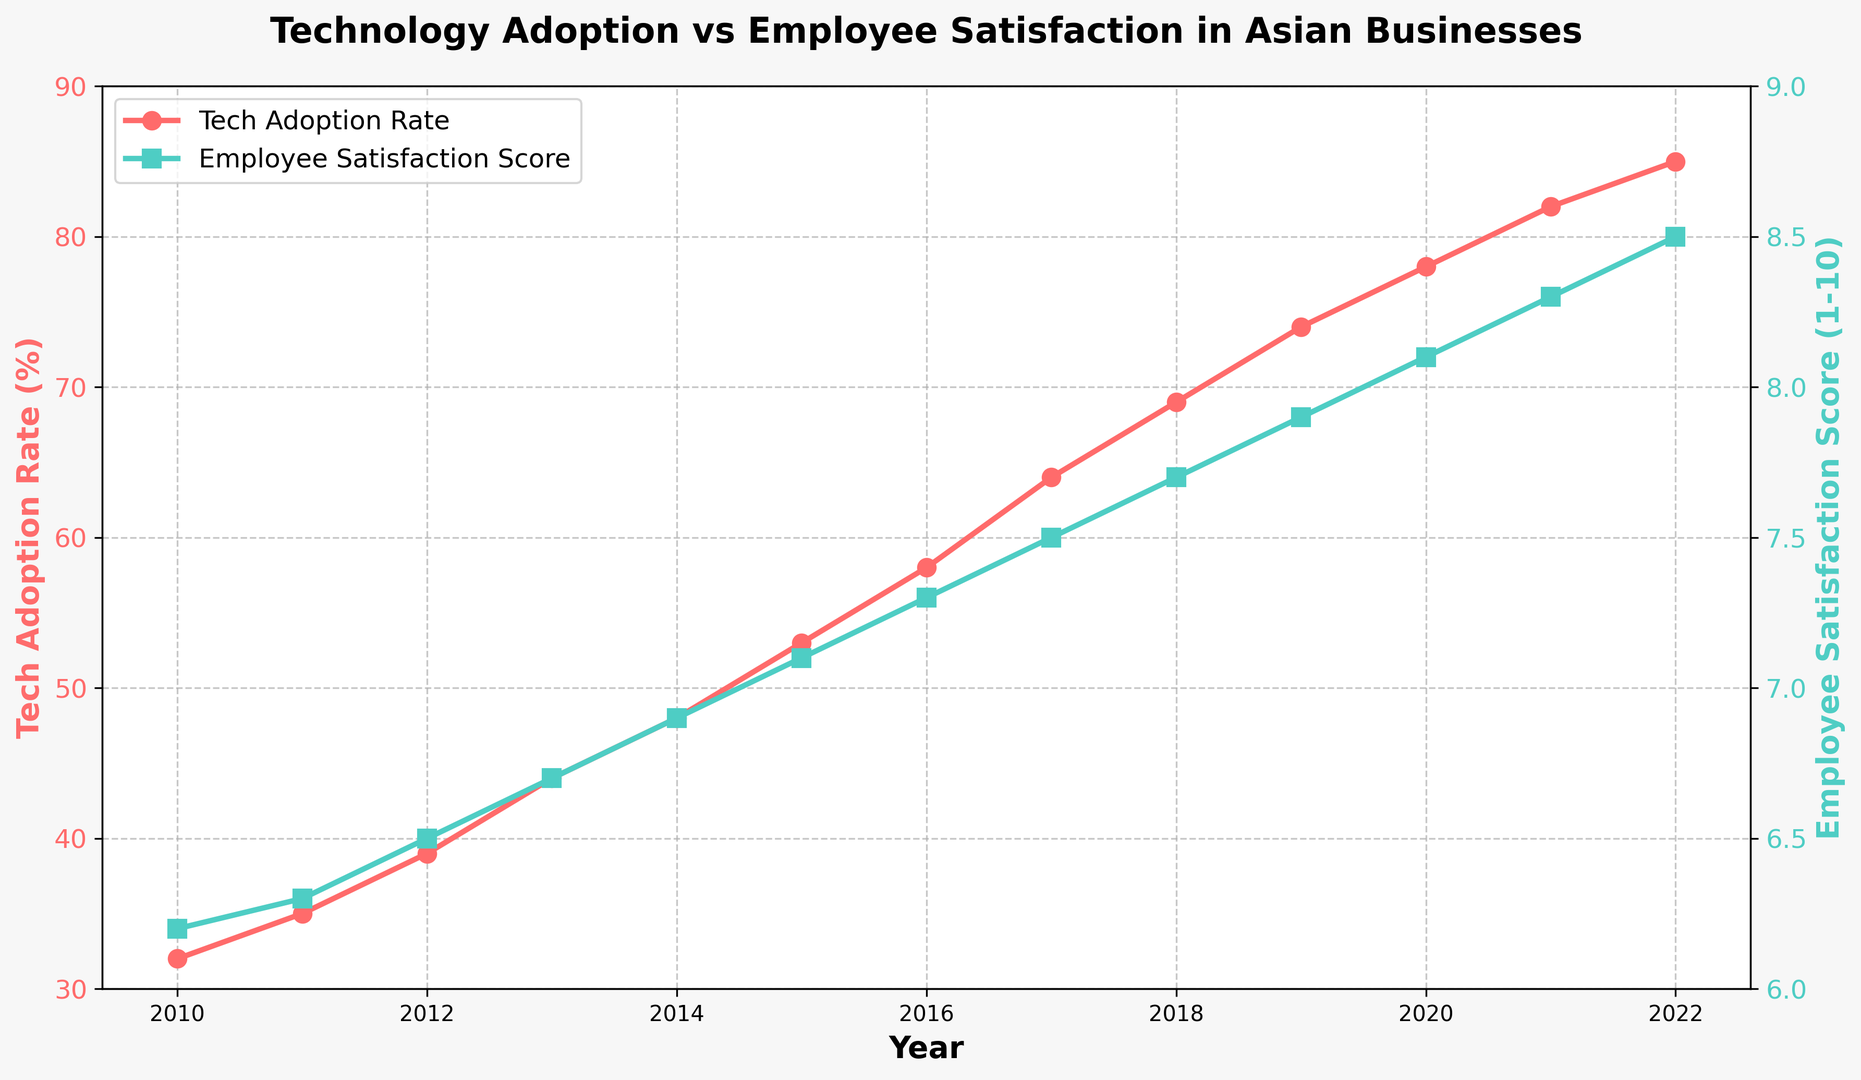What was the Tech Adoption Rate in 2015? Look at the red line on the primary y-axis (Tech Adoption Rate) for the year 2015. The value is plotted as a red dot.
Answer: 53% How did the Employee Satisfaction Score change from 2010 to 2022? Identify the green line's starting point in 2010 and ending point in 2022 on the secondary y-axis. Subtract the initial score from the final score: 8.5 - 6.2
Answer: Increased by 2.3 In which year did the Tech Adoption Rate first exceed 50%? Locate the red line (Tech Adoption Rate) crossing the 50% mark. The corresponding year on the x-axis is 2015.
Answer: 2015 What is the difference in Employee Satisfaction Score between 2016 and 2018? Compare the green line's data points for the years 2016 and 2018. Subtract the 2016 value from the 2018 value: 7.7 - 7.3
Answer: 0.4 Which year saw the highest Tech Adoption Rate? Follow the red line to the highest point on the graph and find the corresponding year on the x-axis. It peaks in 2022 at 85%.
Answer: 2022 Was there ever a year where the Tech Adoption Rate decreased from the previous year? Inspect the red line closely for any downward trend over the years. The line consistently moves upward without any decline.
Answer: No Compare the Employee Satisfaction Scores in 2010 and 2020. Which year had the higher score? Locate the green line's data points for 2010 and 2020 and compare them. 2020 has a value of 8.1, which is higher than 6.2 in 2010.
Answer: 2020 What was the average Tech Adoption Rate from 2010 to 2022? Sum all Tech Adoption Rate values from 2010 to 2022 and divide by the number of years (13). The calculation is (32+35+39+44+48+53+58+64+69+74+78+82+85) / 13 = 59.92
Answer: 59.92% How many years did it take for the Employee Satisfaction Score to go from 6.0 to 8.0? Find the years corresponding to the values on the green line where the score is approximately 6.0 (2010 at 6.2) and 8.0 (2019 at 7.9). Calculate the difference: 2019 - 2010 = 9 years.
Answer: 9 years Was there a significant positive correlation between Tech Adoption Rate and Employee Satisfaction Scores? Both the red and green lines show a consistent upward trend over the years, implying a positive correlation between Tech Adoption Rate and Employee Satisfaction Scores.
Answer: Yes 